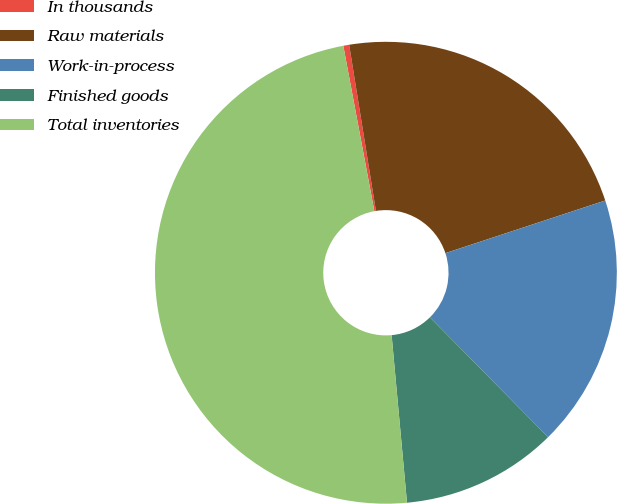Convert chart to OTSL. <chart><loc_0><loc_0><loc_500><loc_500><pie_chart><fcel>In thousands<fcel>Raw materials<fcel>Work-in-process<fcel>Finished goods<fcel>Total inventories<nl><fcel>0.41%<fcel>22.48%<fcel>17.67%<fcel>10.94%<fcel>48.51%<nl></chart> 